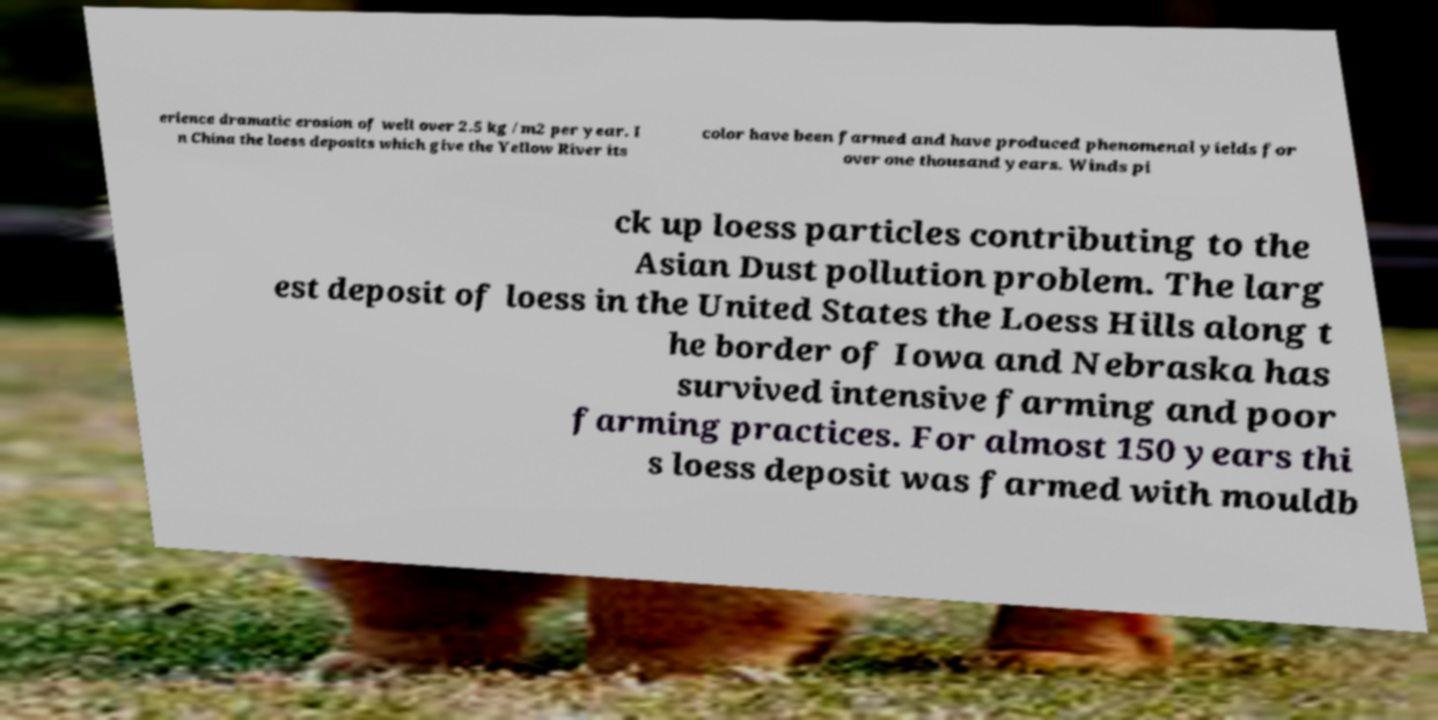Could you extract and type out the text from this image? erience dramatic erosion of well over 2.5 kg /m2 per year. I n China the loess deposits which give the Yellow River its color have been farmed and have produced phenomenal yields for over one thousand years. Winds pi ck up loess particles contributing to the Asian Dust pollution problem. The larg est deposit of loess in the United States the Loess Hills along t he border of Iowa and Nebraska has survived intensive farming and poor farming practices. For almost 150 years thi s loess deposit was farmed with mouldb 